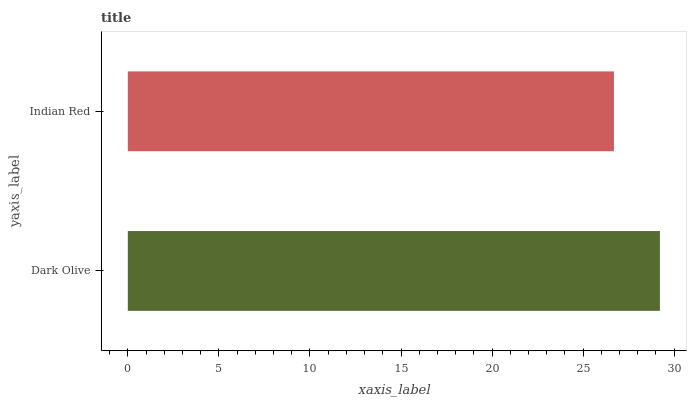Is Indian Red the minimum?
Answer yes or no. Yes. Is Dark Olive the maximum?
Answer yes or no. Yes. Is Indian Red the maximum?
Answer yes or no. No. Is Dark Olive greater than Indian Red?
Answer yes or no. Yes. Is Indian Red less than Dark Olive?
Answer yes or no. Yes. Is Indian Red greater than Dark Olive?
Answer yes or no. No. Is Dark Olive less than Indian Red?
Answer yes or no. No. Is Dark Olive the high median?
Answer yes or no. Yes. Is Indian Red the low median?
Answer yes or no. Yes. Is Indian Red the high median?
Answer yes or no. No. Is Dark Olive the low median?
Answer yes or no. No. 